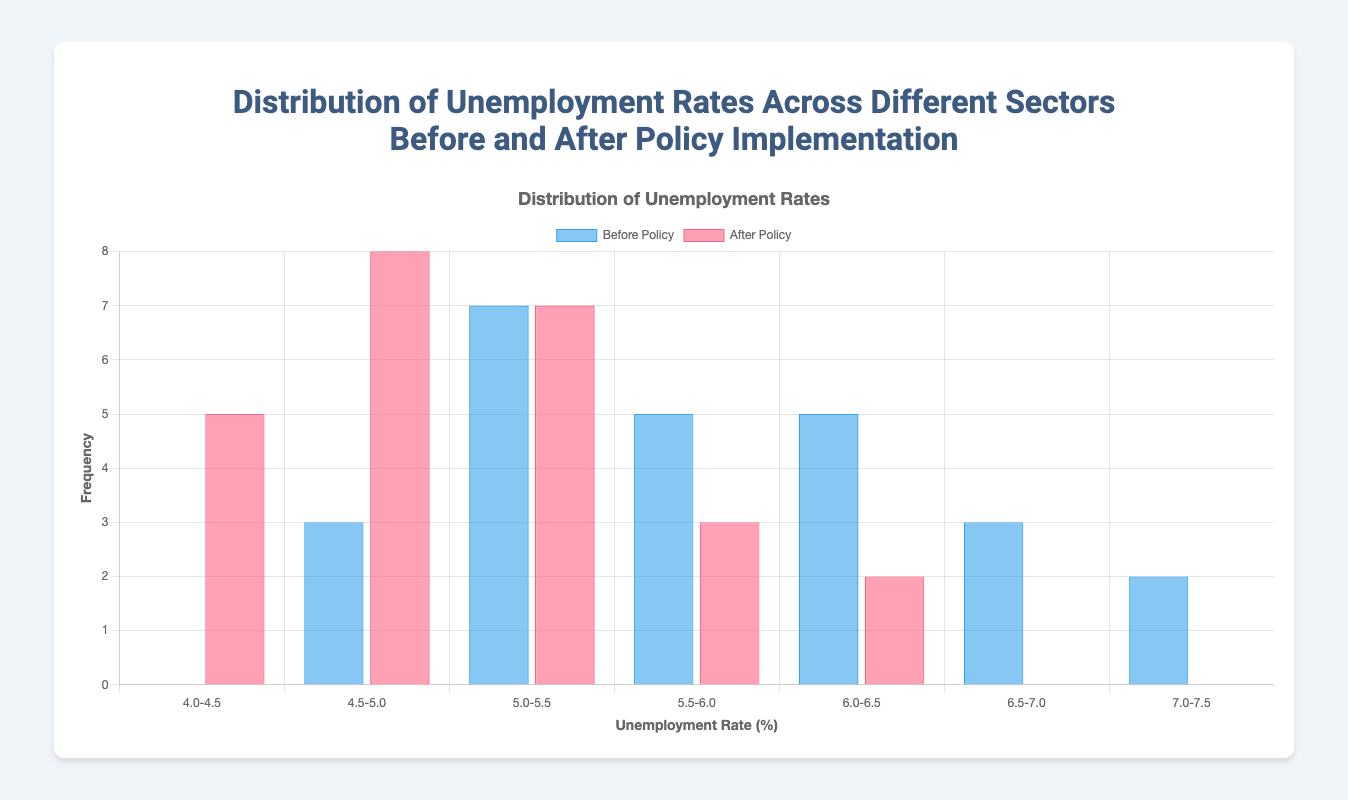What is the title of the figure? The title is located at the top of the figure and indicates what the figure is about.
Answer: Distribution of Unemployment Rates Across Different Sectors Before and After Policy Implementation What are the labels on the x-axis? The x-axis shows the range of unemployment rates divided into intervals. Each label represents one of these intervals.
Answer: 4.0-4.5, 4.5-5.0, 5.0-5.5, 5.5-6.0, 6.0-6.5, 6.5-7.0, 7.0-7.5 What colors represent the 'Before Policy' and 'After Policy' datasets? The 'Before Policy' dataset is represented using a blue color, and the 'After Policy' dataset is represented using a red color.
Answer: Blue and Red How many intervals have no data points for the 'After Policy' dataset? The 'After Policy' bar chart has zero data points in the 6.5-7.0 and 7.0-7.5 intervals.
Answer: 2 Which interval shows the highest frequency of unemployment rates after the policy implementation? The bar representing the interval with the highest frequency in the 'After Policy' dataset can be identified by checking the heights of the bars.
Answer: 4.5-5.0 How does the frequency of the 5.0-5.5 interval compare before and after the policy implementation? Compare the height of the bars for the 5.0-5.5 interval in both the 'Before Policy' and 'After Policy' datasets.
Answer: It's equal What is the change in frequency for the 6.0-6.5 interval from before to after the policy? Subtract the frequency of the 6.0-6.5 interval 'After Policy' from the frequency 'Before Policy'.
Answer: -3 Which interval has an exclusive frequency in the 'After Policy' dataset compared to ‘Before Policy’? Identify the interval where one dataset has no data points, while other dataset has at least one.
Answer: 4.0-4.5 What is the total frequency of observed data points in the 'Before Policy' dataset across all intervals? Sum the frequencies of all the intervals in the 'Before Policy' dataset: 0 + 3 + 7 + 5 + 5 + 3 + 2 = 25
Answer: 25 Which intervals show a decrease in frequency from before to after the policy implementation? Compare the frequencies of each interval in both datasets to determine where there is a decrease.
Answer: 5.5-6.0, 6.0-6.5, 6.5-7.0, 7.0-7.5 